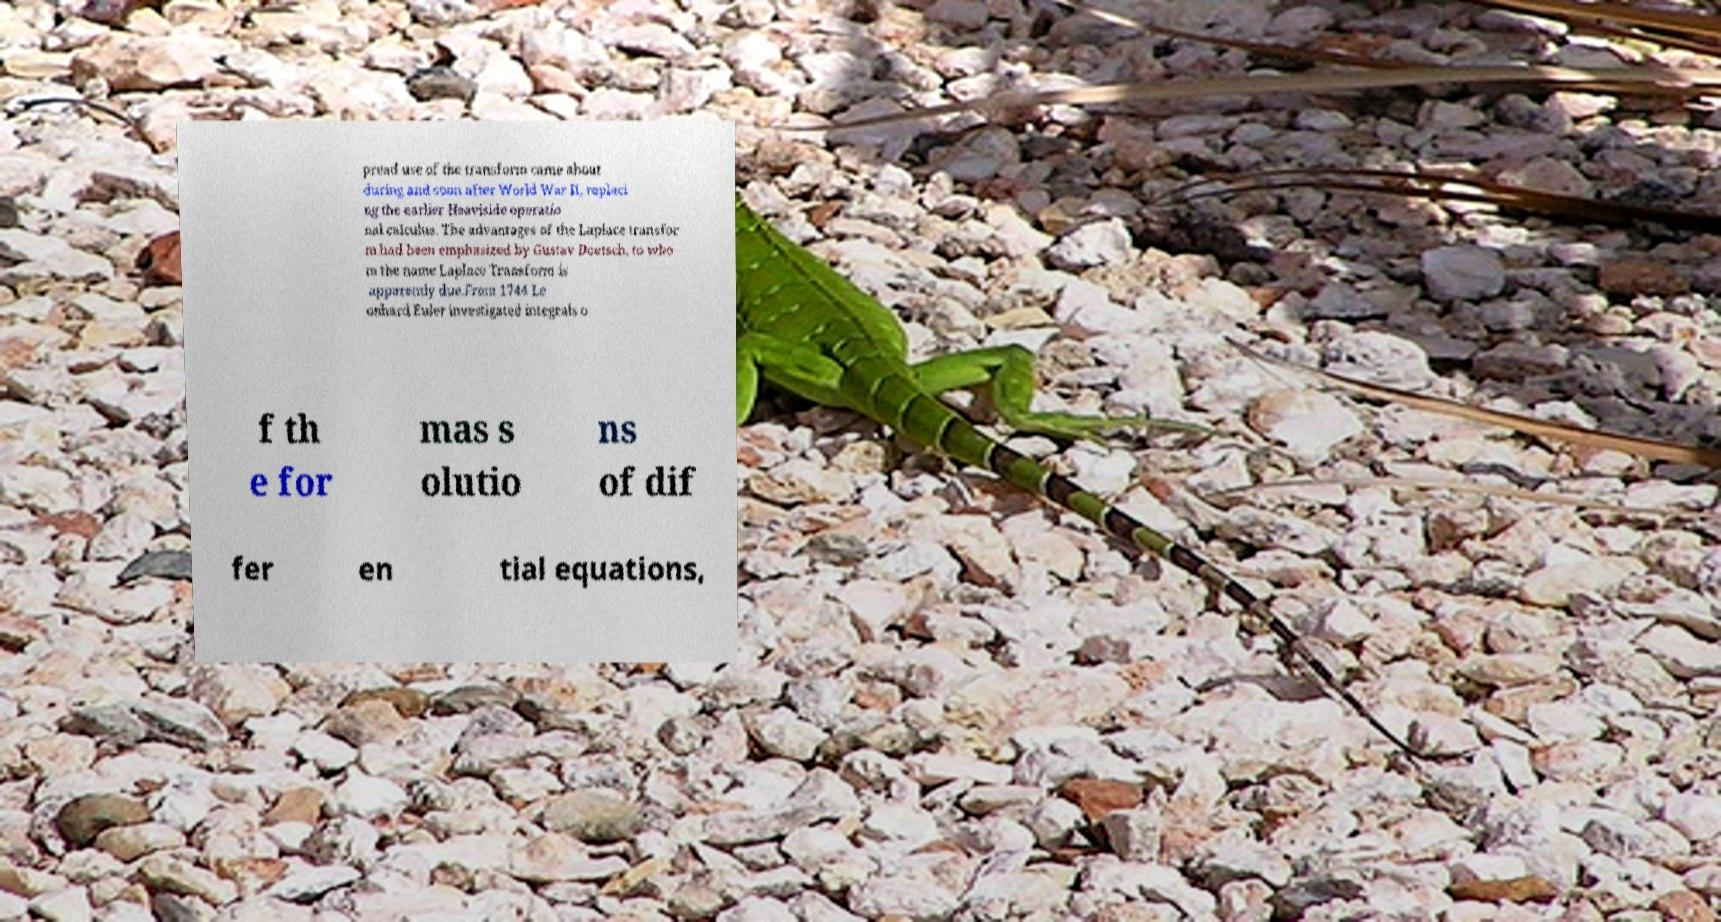Please read and relay the text visible in this image. What does it say? pread use of the transform came about during and soon after World War II, replaci ng the earlier Heaviside operatio nal calculus. The advantages of the Laplace transfor m had been emphasized by Gustav Doetsch, to who m the name Laplace Transform is apparently due.From 1744 Le onhard Euler investigated integrals o f th e for mas s olutio ns of dif fer en tial equations, 